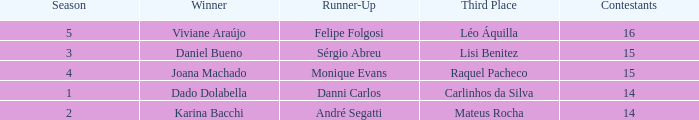In what season did Raquel Pacheco finish in third place? 4.0. Parse the table in full. {'header': ['Season', 'Winner', 'Runner-Up', 'Third Place', 'Contestants'], 'rows': [['5', 'Viviane Araújo', 'Felipe Folgosi', 'Léo Áquilla', '16'], ['3', 'Daniel Bueno', 'Sérgio Abreu', 'Lisi Benitez', '15'], ['4', 'Joana Machado', 'Monique Evans', 'Raquel Pacheco', '15'], ['1', 'Dado Dolabella', 'Danni Carlos', 'Carlinhos da Silva', '14'], ['2', 'Karina Bacchi', 'André Segatti', 'Mateus Rocha', '14']]} 